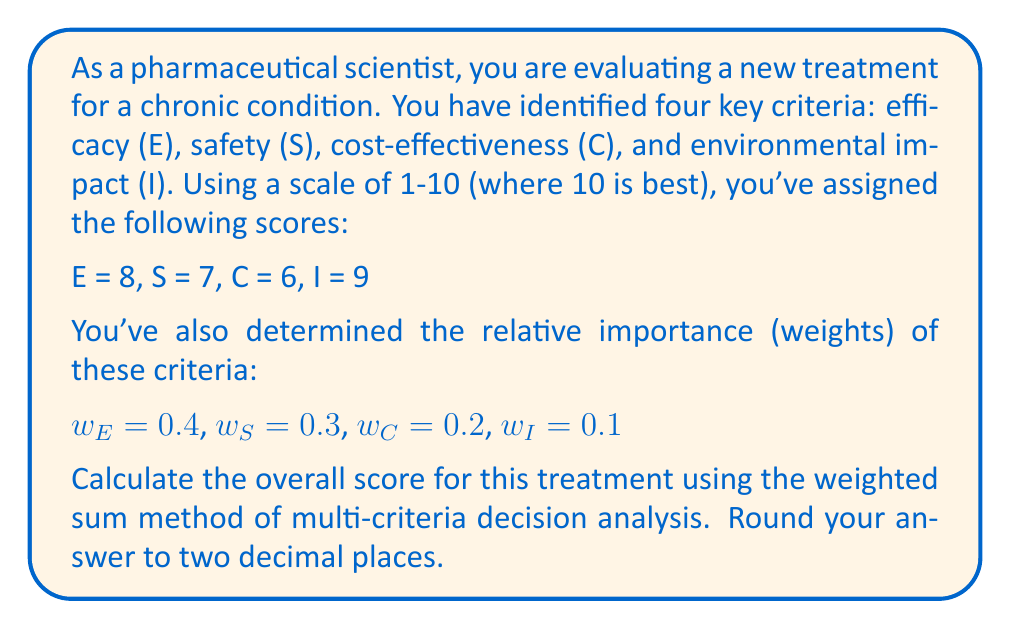Help me with this question. To solve this problem, we'll use the weighted sum method of multi-criteria decision analysis. This method involves multiplying each criterion score by its corresponding weight and then summing these products.

The formula for the weighted sum is:

$$\text{Overall Score} = \sum_{i=1}^n w_i \cdot c_i$$

Where:
$w_i$ is the weight of criterion $i$
$c_i$ is the score of criterion $i$
$n$ is the number of criteria

Let's calculate each term:

1. Efficacy: $w_E \cdot E = 0.4 \cdot 8 = 3.2$
2. Safety: $w_S \cdot S = 0.3 \cdot 7 = 2.1$
3. Cost-effectiveness: $w_C \cdot C = 0.2 \cdot 6 = 1.2$
4. Environmental impact: $w_I \cdot I = 0.1 \cdot 9 = 0.9$

Now, we sum these products:

$$\text{Overall Score} = 3.2 + 2.1 + 1.2 + 0.9 = 7.4$$

Rounding to two decimal places, the final answer is 7.40.
Answer: 7.40 